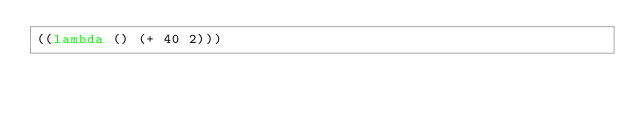<code> <loc_0><loc_0><loc_500><loc_500><_Scheme_>((lambda () (+ 40 2)))</code> 